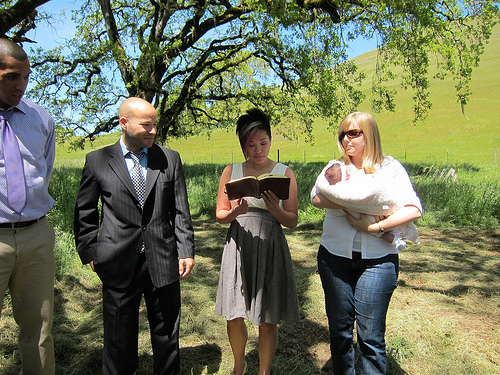<image>
Is there a book in front of the girl? Yes. The book is positioned in front of the girl, appearing closer to the camera viewpoint. Is there a man in front of the baby? No. The man is not in front of the baby. The spatial positioning shows a different relationship between these objects. 